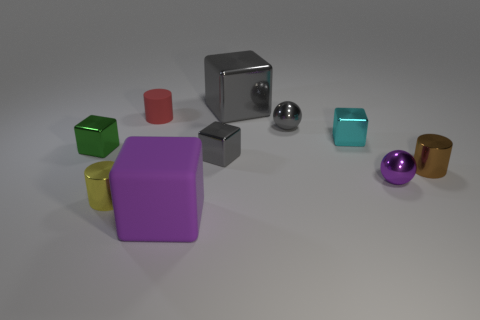What size is the gray metal block in front of the red matte cylinder?
Offer a terse response. Small. Is the number of purple spheres less than the number of small purple matte cylinders?
Keep it short and to the point. No. Is there a matte sphere of the same color as the small matte object?
Ensure brevity in your answer.  No. What is the shape of the thing that is both on the left side of the small brown object and to the right of the cyan cube?
Keep it short and to the point. Sphere. The purple thing that is to the right of the rubber object in front of the brown metallic object is what shape?
Your answer should be very brief. Sphere. Is the yellow shiny thing the same shape as the small purple object?
Your response must be concise. No. There is a object that is the same color as the rubber cube; what is its material?
Your answer should be very brief. Metal. Do the small rubber cylinder and the big metallic cube have the same color?
Offer a very short reply. No. There is a tiny cylinder that is to the right of the thing in front of the yellow thing; how many green objects are in front of it?
Ensure brevity in your answer.  0. What shape is the big purple thing that is made of the same material as the tiny red thing?
Offer a terse response. Cube. 